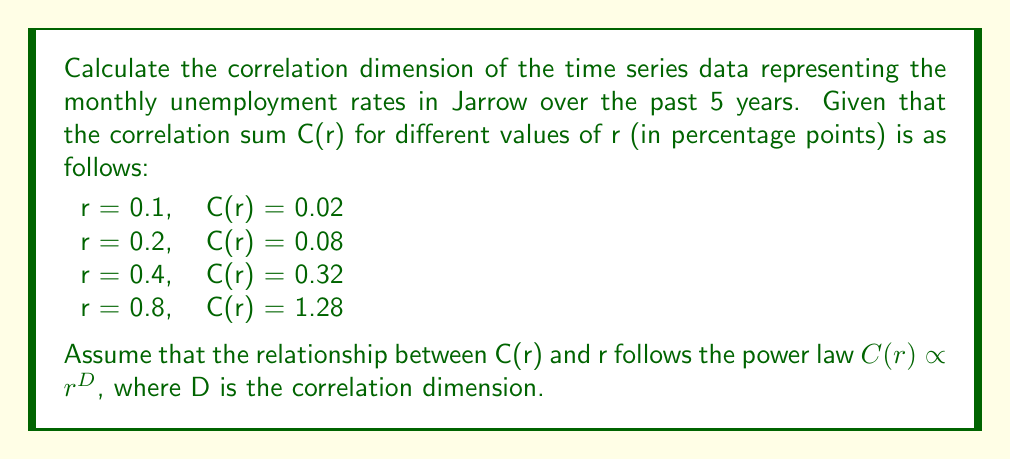Give your solution to this math problem. To calculate the correlation dimension, we'll follow these steps:

1) The correlation dimension D is given by the slope of the log-log plot of C(r) vs r.

2) We can express the power law relationship as:
   $\log(C(r)) = D \log(r) + \log(k)$, where k is a constant.

3) Let's create a table of log(r) and log(C(r)):

   | r   | C(r) | log(r)       | log(C(r))     |
   |-----|------|--------------|---------------|
   | 0.1 | 0.02 | -2.30258509  | -3.91202301   |
   | 0.2 | 0.08 | -1.60943791  | -2.52572864   |
   | 0.4 | 0.32 | -0.91629073  | -1.13943428   |
   | 0.8 | 1.28 |  -0.22314355 |  0.24686749   |

4) To find the slope, we can use the formula:
   $$D = \frac{n\sum(xy) - \sum x \sum y}{n\sum x^2 - (\sum x)^2}$$
   where x = log(r) and y = log(C(r))

5) Calculating the required sums:
   $\sum x = -5.05145728$
   $\sum y = -7.33031844$
   $\sum xy = 13.10678854$
   $\sum x^2 = 9.85430515$
   n = 4

6) Plugging these values into the formula:
   $$D = \frac{4(13.10678854) - (-5.05145728)(-7.33031844)}{4(9.85430515) - (-5.05145728)^2}$$

7) Simplifying:
   $$D = \frac{52.42715416 + 37.02960075}{39.41722060 - 25.51722767} = \frac{89.45675491}{13.90000293} = 6.43573051$$

Therefore, the correlation dimension of the time series is approximately 6.44.
Answer: 6.44 